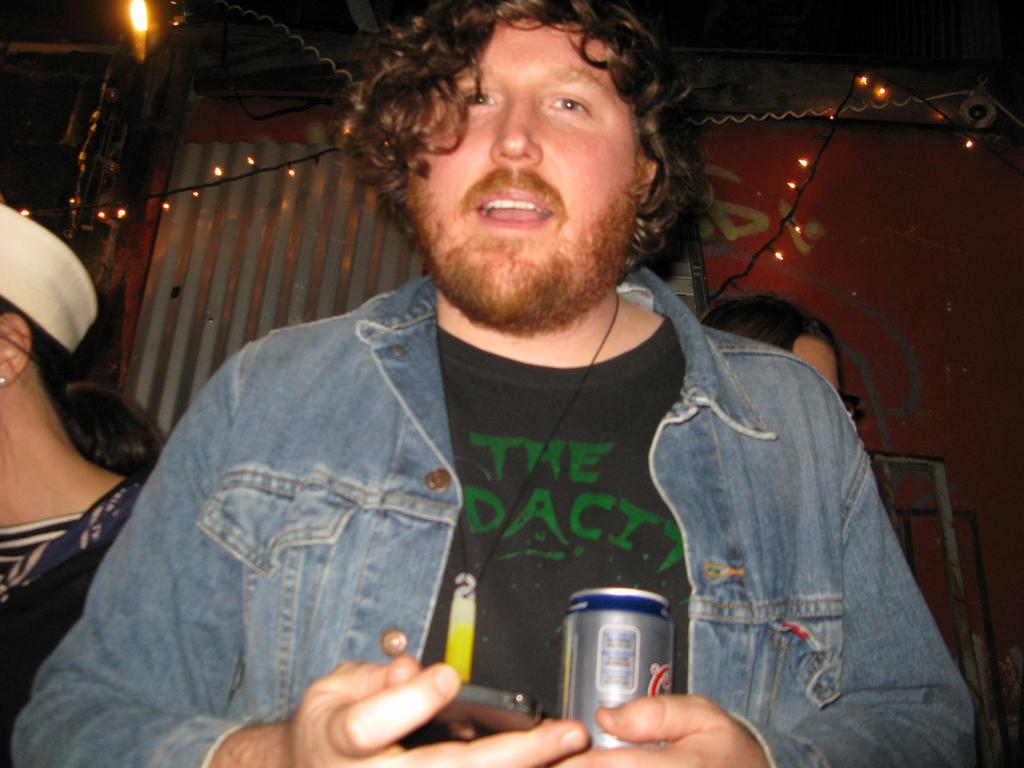How many people are in the image? There are three people in the image. What are the people doing in the image? The people are standing. Which person is in the center of the image? The person in the center is holding a coke and a mobile. What can be seen in the background of the image? There are lights and a red wall visible in the background of the image. What scent is being emitted by the thing in the image? There is no "thing" present in the image, and therefore no scent can be associated with it. 